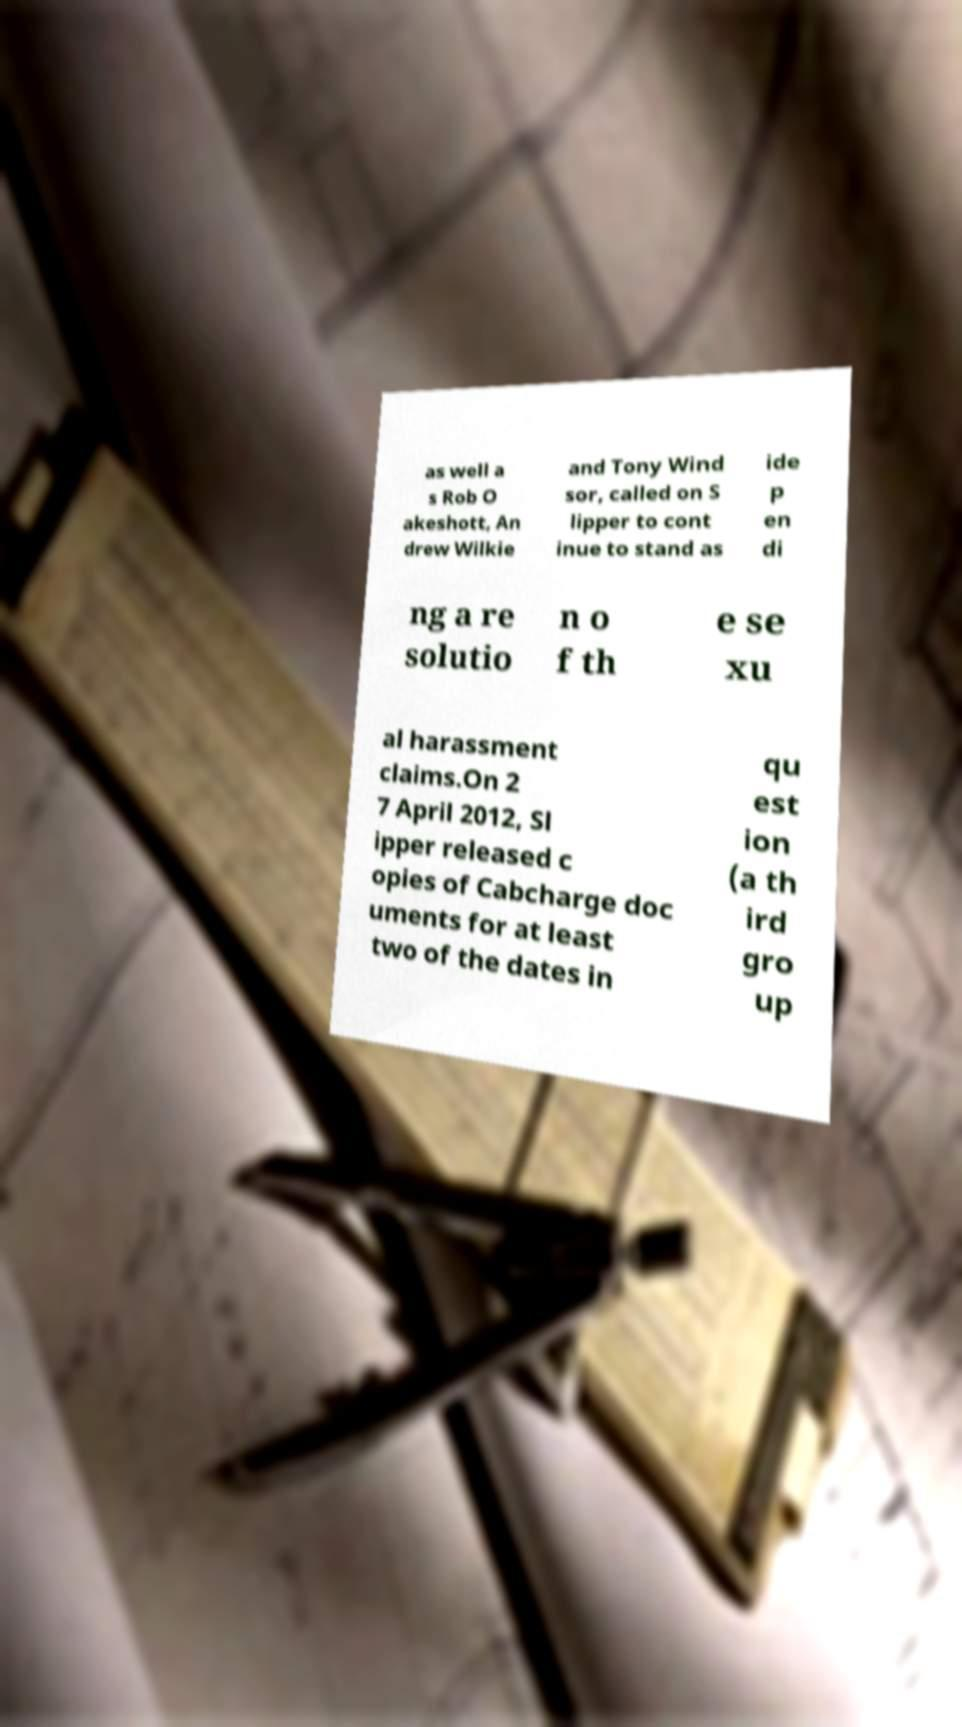Please read and relay the text visible in this image. What does it say? as well a s Rob O akeshott, An drew Wilkie and Tony Wind sor, called on S lipper to cont inue to stand as ide p en di ng a re solutio n o f th e se xu al harassment claims.On 2 7 April 2012, Sl ipper released c opies of Cabcharge doc uments for at least two of the dates in qu est ion (a th ird gro up 